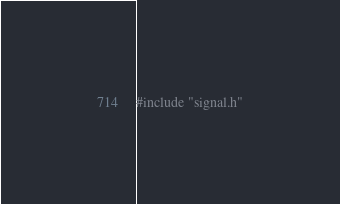<code> <loc_0><loc_0><loc_500><loc_500><_C_>
#include "signal.h"
</code> 